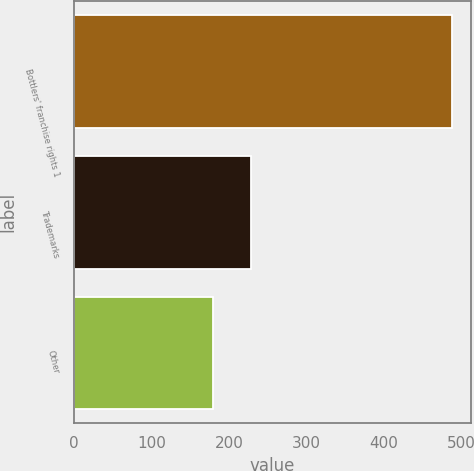Convert chart. <chart><loc_0><loc_0><loc_500><loc_500><bar_chart><fcel>Bottlers' franchise rights 1<fcel>Trademarks<fcel>Other<nl><fcel>487<fcel>228<fcel>179<nl></chart> 